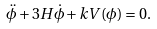Convert formula to latex. <formula><loc_0><loc_0><loc_500><loc_500>\ddot { \phi } + 3 H \dot { \phi } + k V ( \phi ) = 0 .</formula> 